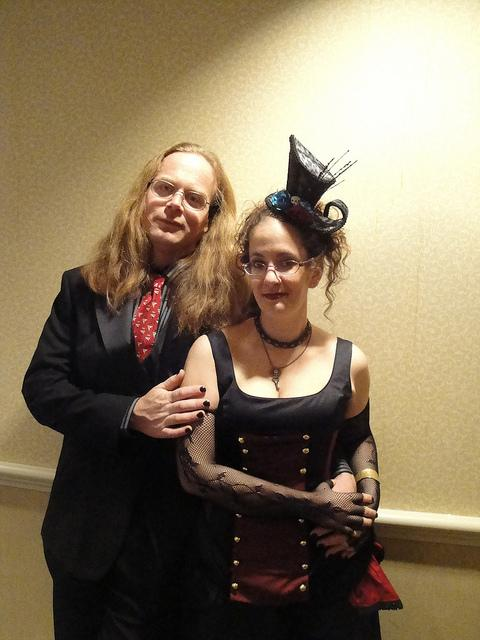Why is the woman wearing a hat?

Choices:
A) costume
B) warmth
C) safety
D) uniform costume 